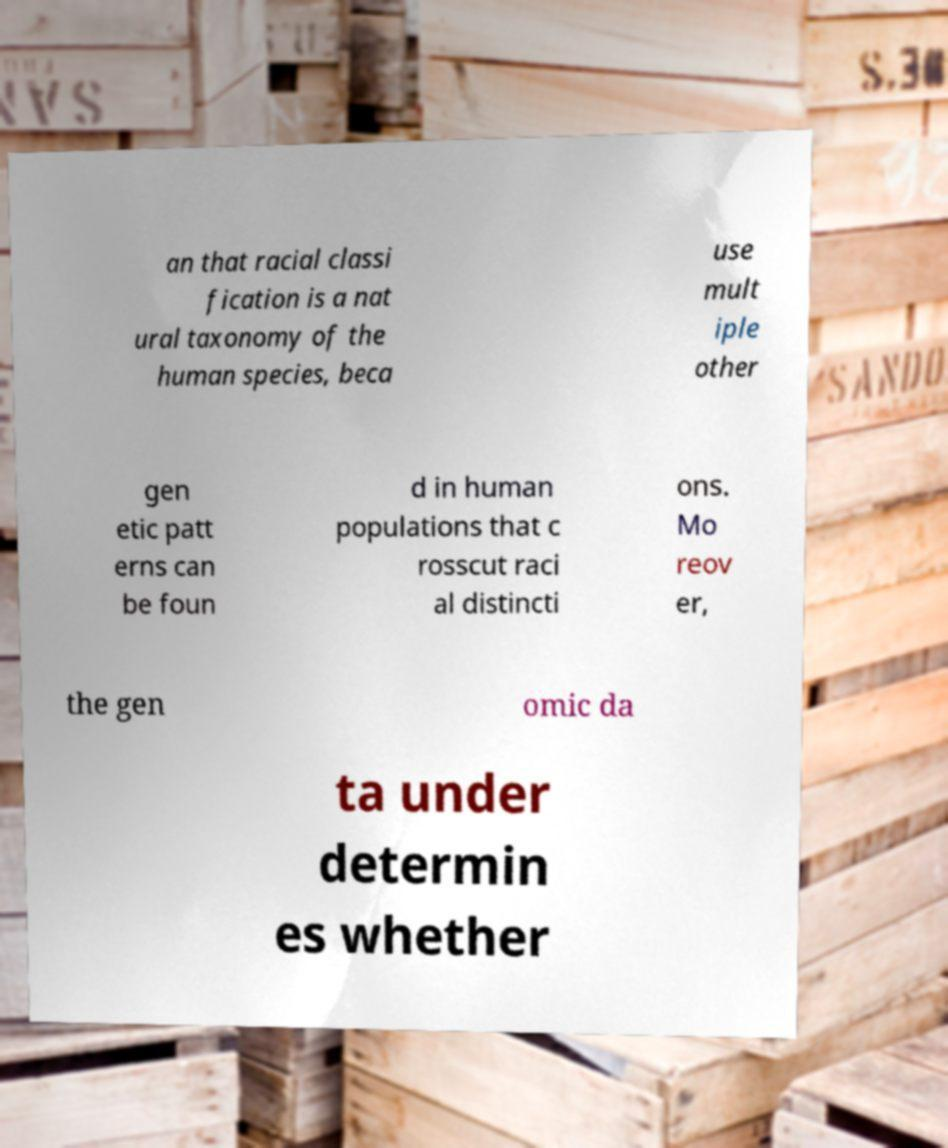I need the written content from this picture converted into text. Can you do that? an that racial classi fication is a nat ural taxonomy of the human species, beca use mult iple other gen etic patt erns can be foun d in human populations that c rosscut raci al distincti ons. Mo reov er, the gen omic da ta under determin es whether 